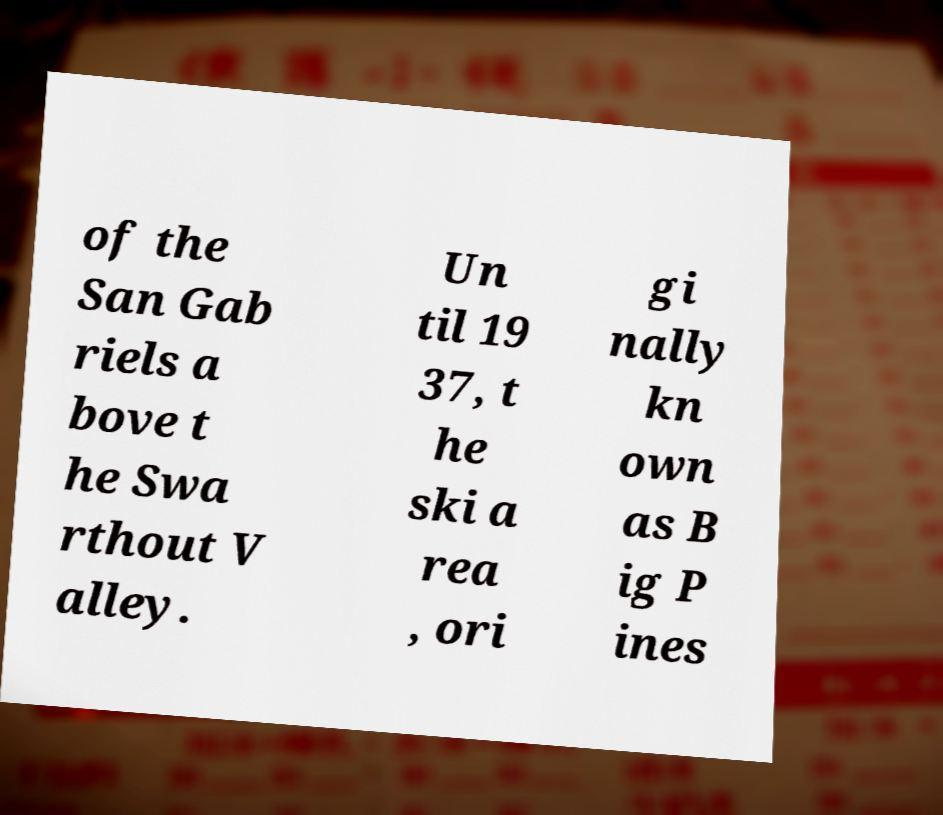What messages or text are displayed in this image? I need them in a readable, typed format. of the San Gab riels a bove t he Swa rthout V alley. Un til 19 37, t he ski a rea , ori gi nally kn own as B ig P ines 